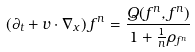<formula> <loc_0><loc_0><loc_500><loc_500>\left ( \partial _ { t } + v \cdot \nabla _ { x } \right ) f ^ { n } = \frac { Q ( f ^ { n } , f ^ { n } ) } { 1 + \frac { 1 } { n } \rho _ { f ^ { n } } }</formula> 